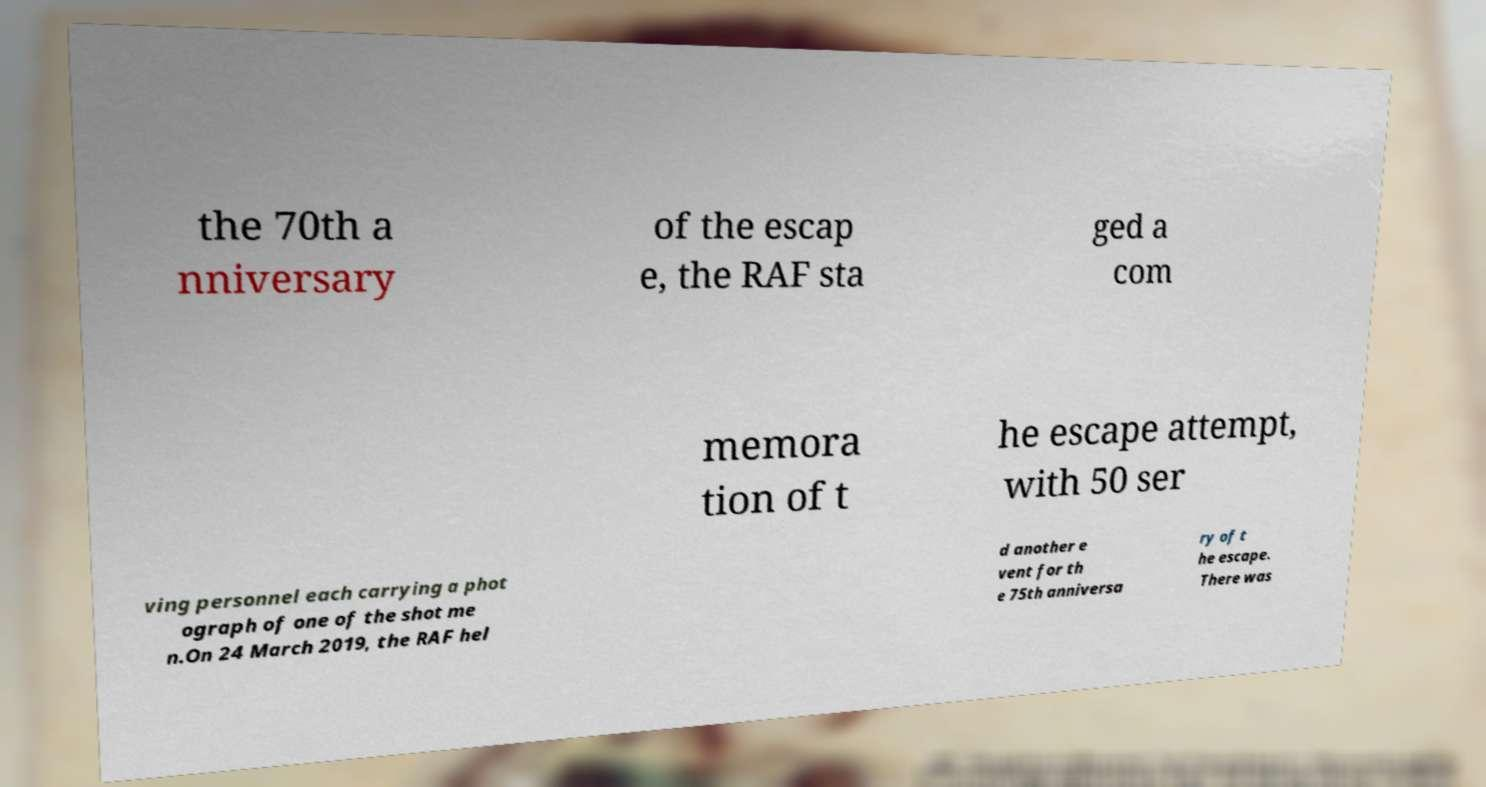For documentation purposes, I need the text within this image transcribed. Could you provide that? the 70th a nniversary of the escap e, the RAF sta ged a com memora tion of t he escape attempt, with 50 ser ving personnel each carrying a phot ograph of one of the shot me n.On 24 March 2019, the RAF hel d another e vent for th e 75th anniversa ry of t he escape. There was 